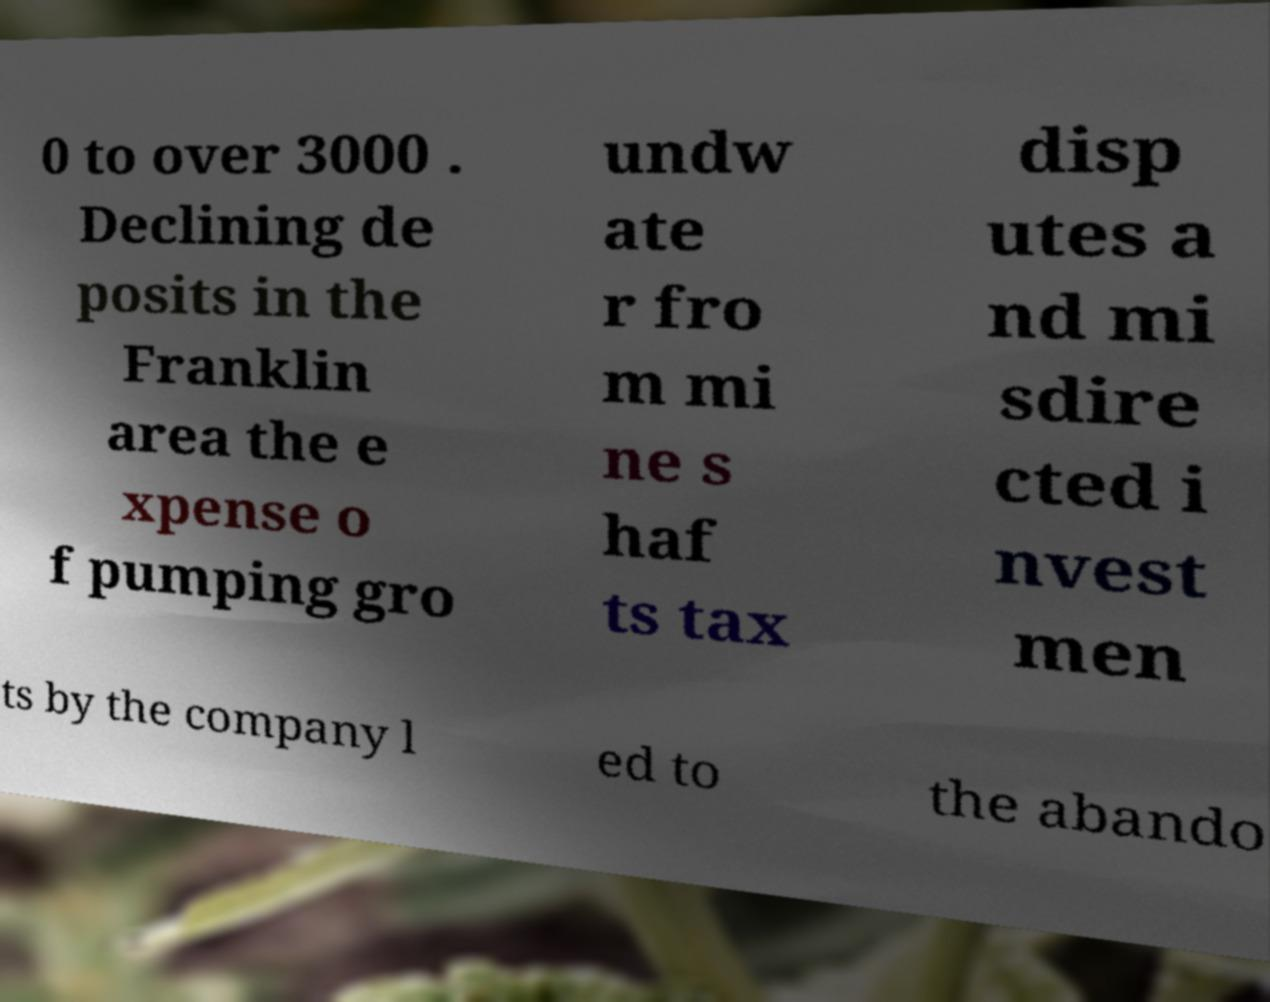Can you accurately transcribe the text from the provided image for me? 0 to over 3000 . Declining de posits in the Franklin area the e xpense o f pumping gro undw ate r fro m mi ne s haf ts tax disp utes a nd mi sdire cted i nvest men ts by the company l ed to the abando 